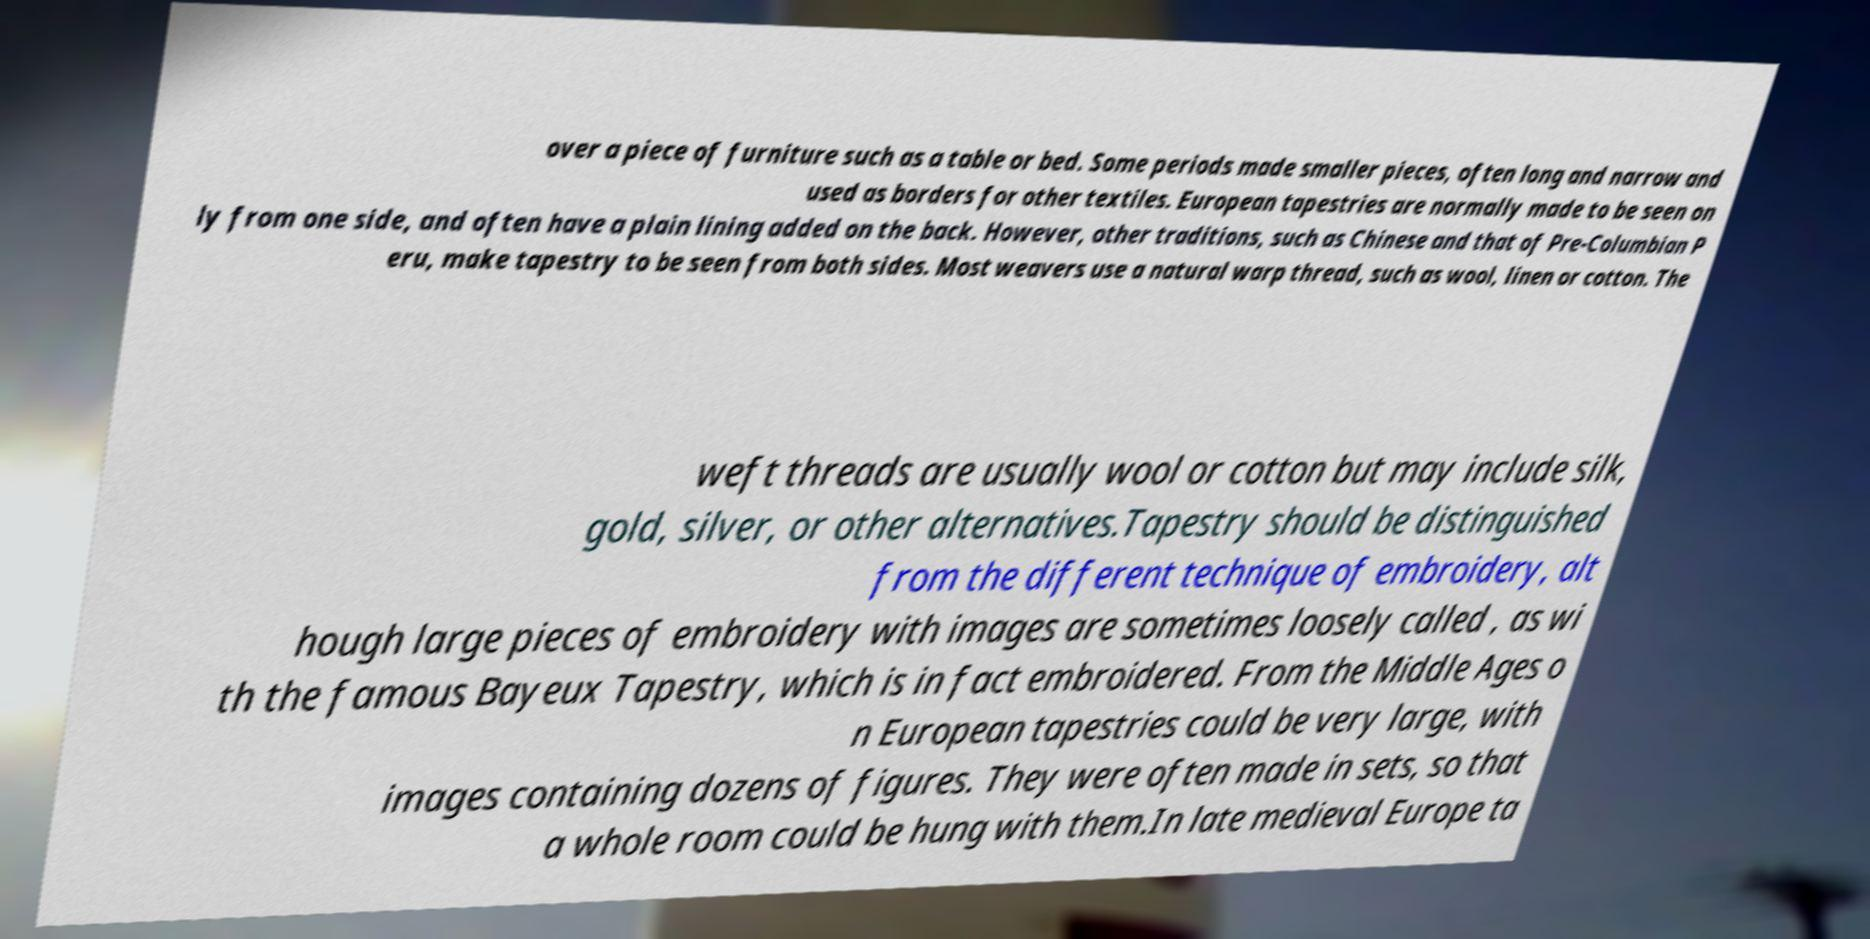What messages or text are displayed in this image? I need them in a readable, typed format. over a piece of furniture such as a table or bed. Some periods made smaller pieces, often long and narrow and used as borders for other textiles. European tapestries are normally made to be seen on ly from one side, and often have a plain lining added on the back. However, other traditions, such as Chinese and that of Pre-Columbian P eru, make tapestry to be seen from both sides. Most weavers use a natural warp thread, such as wool, linen or cotton. The weft threads are usually wool or cotton but may include silk, gold, silver, or other alternatives.Tapestry should be distinguished from the different technique of embroidery, alt hough large pieces of embroidery with images are sometimes loosely called , as wi th the famous Bayeux Tapestry, which is in fact embroidered. From the Middle Ages o n European tapestries could be very large, with images containing dozens of figures. They were often made in sets, so that a whole room could be hung with them.In late medieval Europe ta 